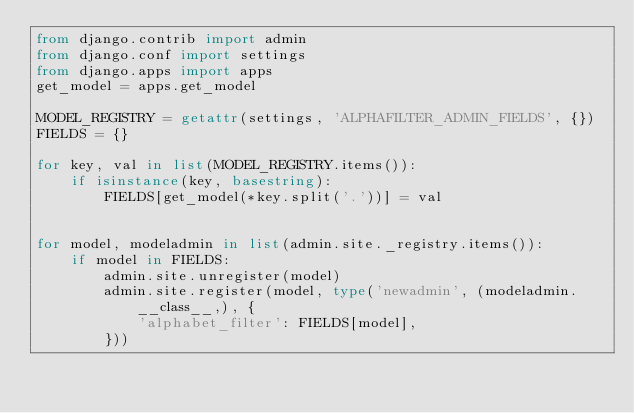<code> <loc_0><loc_0><loc_500><loc_500><_Python_>from django.contrib import admin
from django.conf import settings
from django.apps import apps
get_model = apps.get_model

MODEL_REGISTRY = getattr(settings, 'ALPHAFILTER_ADMIN_FIELDS', {})
FIELDS = {}

for key, val in list(MODEL_REGISTRY.items()):
    if isinstance(key, basestring):
        FIELDS[get_model(*key.split('.'))] = val


for model, modeladmin in list(admin.site._registry.items()):
    if model in FIELDS:
        admin.site.unregister(model)
        admin.site.register(model, type('newadmin', (modeladmin.__class__,), {
            'alphabet_filter': FIELDS[model],
        }))
</code> 